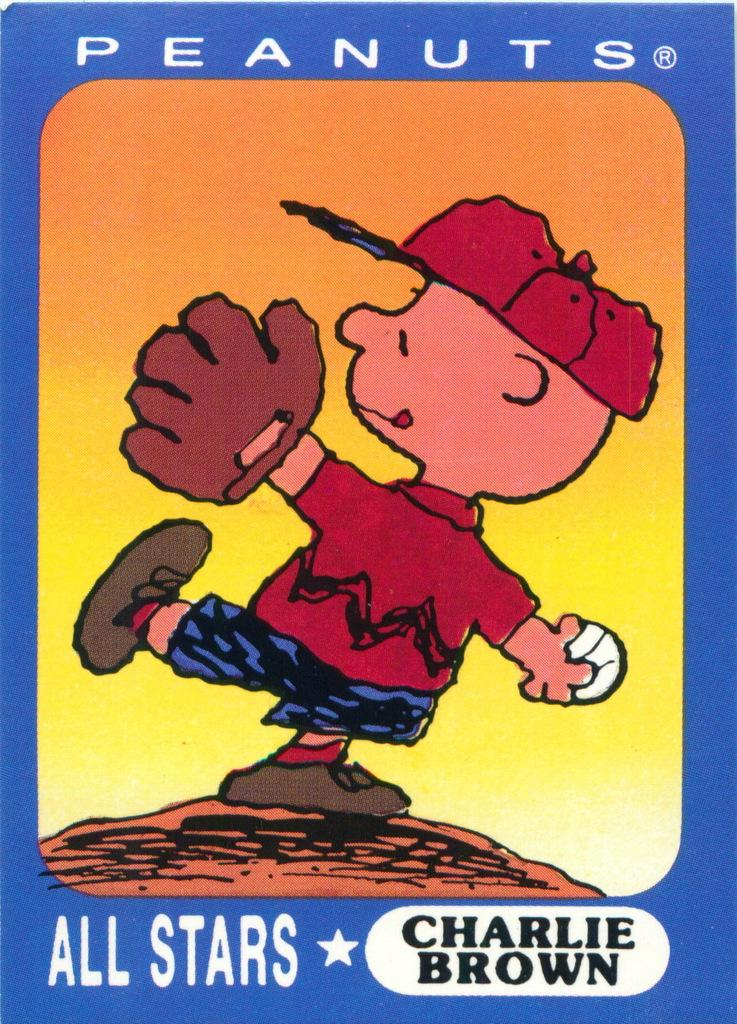What is featured in the image? There is a poster in the image. What is the main image on the poster? The poster depicts a person throwing a ball. Are there any words on the poster? Yes, there is text on the poster. How many stamps are visible on the poster? There are no stamps present on the poster; it features a person throwing a ball and text. What type of station is shown in the image? There is no station depicted in the image; it only features a poster with a person throwing a ball and text. 